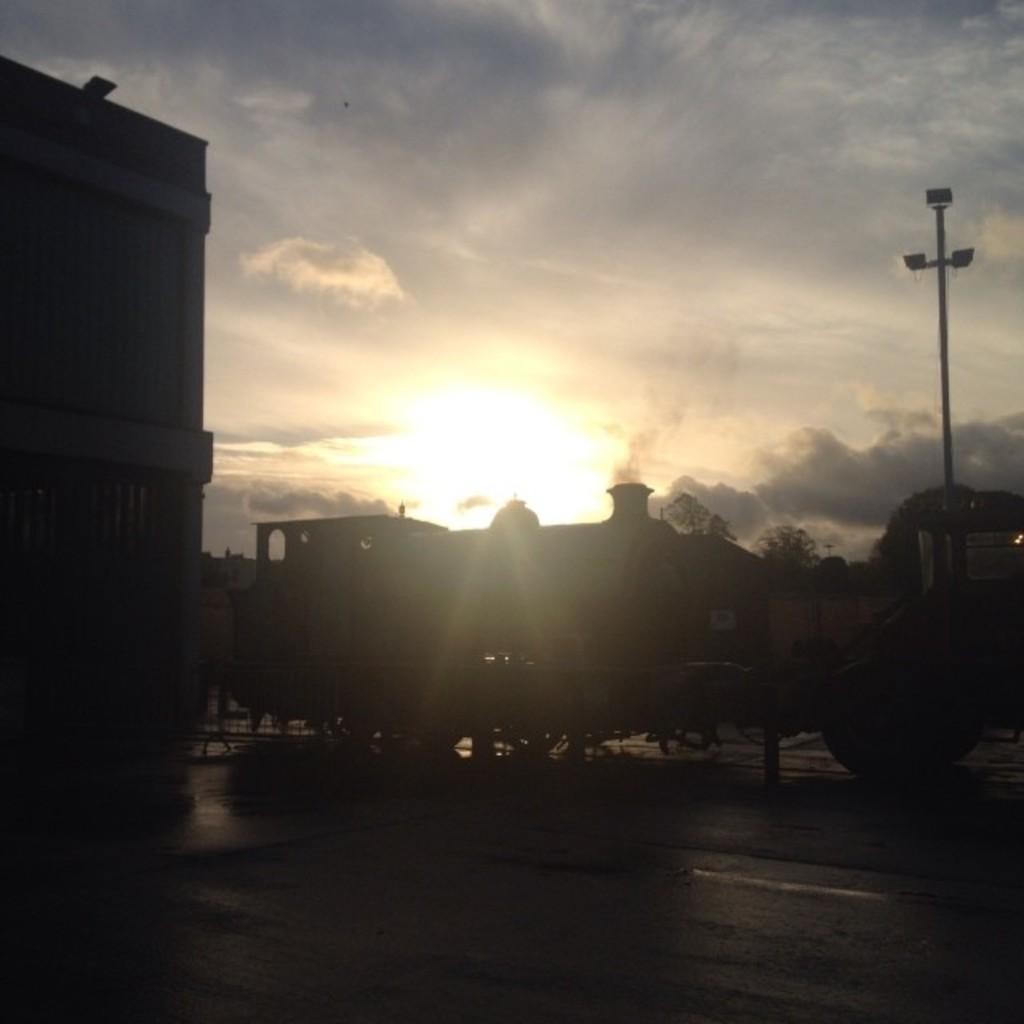Please provide a concise description of this image. In this image in the center there are vehicles and in the background there are buildings, trees and the sky is cloudy. On the right side there is a pole. 